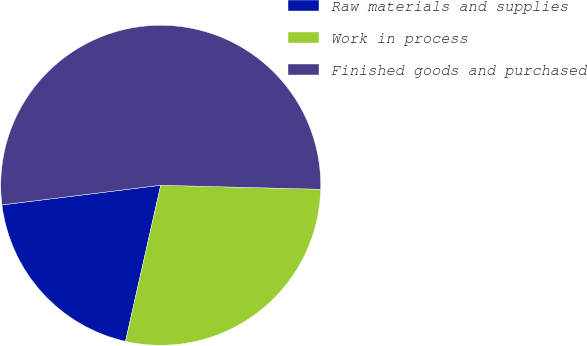Convert chart to OTSL. <chart><loc_0><loc_0><loc_500><loc_500><pie_chart><fcel>Raw materials and supplies<fcel>Work in process<fcel>Finished goods and purchased<nl><fcel>19.51%<fcel>28.13%<fcel>52.36%<nl></chart> 